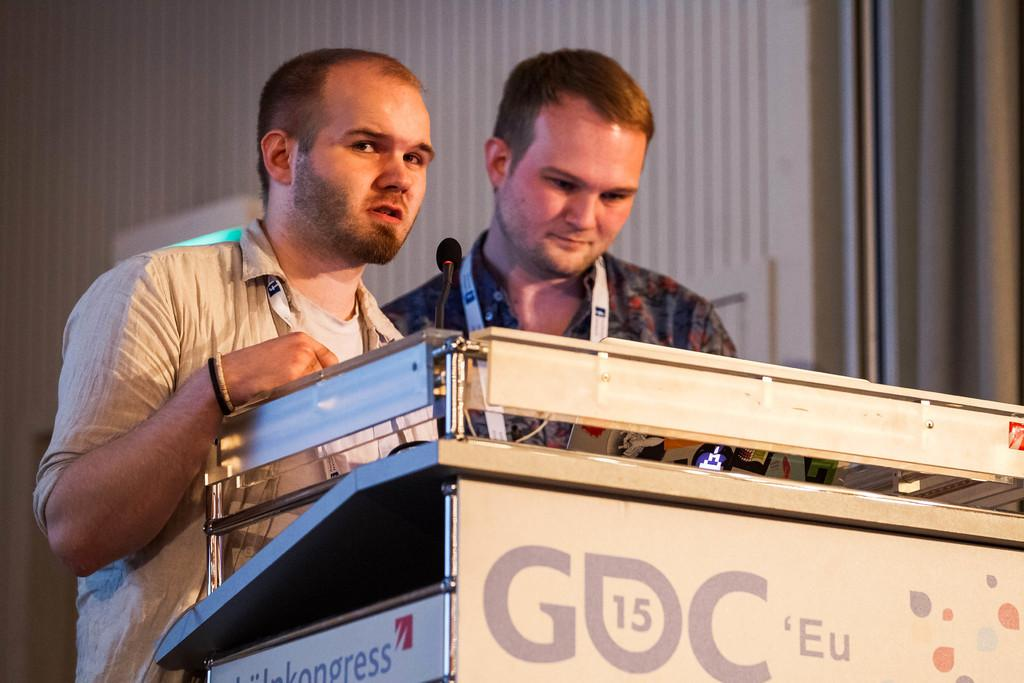How many boys are present in the image? There are two boys in the image. What are the boys doing in the image? The boys are standing near a podium. What is on the podium? There is a microphone on the podium. What can be seen in the background of the image? There is a wall in the background of the image. What might indicate that the boys are attending an event or gathering? Both boys are wearing ID cards. What type of flame can be seen on the podium in the image? There is no flame present on the podium or anywhere in the image. 